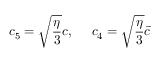Convert formula to latex. <formula><loc_0><loc_0><loc_500><loc_500>c _ { 5 } = \sqrt { \frac { \eta } { 3 } } c , \quad c _ { 4 } = \sqrt { \frac { \eta } { 3 } } \bar { c }</formula> 